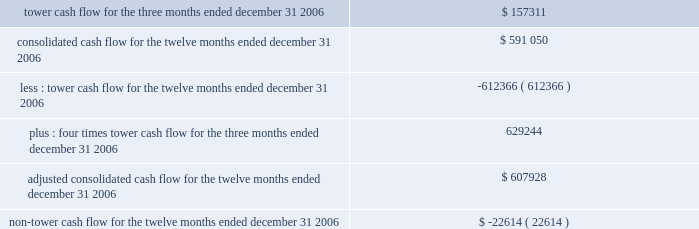In february 2007 , the fasb issued sfas no .
159 201cthe fair value option for financial assets and liabilities 2014including an amendment of fasb statement no .
115 201d ( sfas no .
159 ) .
This statement provides companies with an option to report selected financial assets and liabilities at fair value and establishes presentation and disclosure requirements designed to facilitate comparisons between companies that choose different measurement attributes for similar types of assets and liabilities .
Sfas no .
159 is effective for us as of january 1 , 2008 .
We are in the process of evaluating the impact that sfas no .
159 will have on our consolidated financial statements .
Information presented pursuant to the indentures of our 7.50% ( 7.50 % ) notes , 7.125% ( 7.125 % ) notes and ati 7.25% ( 7.25 % ) the table sets forth information that is presented solely to address certain tower cash flow reporting requirements contained in the indentures for our 7.50% ( 7.50 % ) notes , 7.125% ( 7.125 % ) notes and ati 7.25% ( 7.25 % ) notes ( collectively , the notes ) .
The information contained in note 20 to our consolidated financial statements is also presented to address certain reporting requirements contained in the indenture for our ati 7.25% ( 7.25 % ) notes .
The indentures governing the notes contain restrictive covenants with which we and certain subsidiaries under these indentures must comply .
These include restrictions on our ability to incur additional debt , guarantee debt , pay dividends and make other distributions and make certain investments .
Any failure to comply with these covenants would constitute a default , which could result in the acceleration of the principal amount and accrued and unpaid interest on all the outstanding notes .
In order for the holders of the notes to assess our compliance with certain of these covenants , the indentures require us to disclose in the periodic reports we file with the sec our tower cash flow , adjusted consolidated cash flow and non-tower cash flow ( each as defined in the indentures ) .
Under the indentures , our ability to make certain types of restricted payments is limited by the amount of adjusted consolidated cash flow that we generate , which is determined based on our tower cash flow and non-tower cash flow .
In addition , the indentures for the notes restrict us from incurring additional debt or issuing certain types of preferred stock if on a pro forma basis the issuance of such debt and preferred stock would cause our consolidated debt to be greater than 7.5 times our adjusted consolidated cash flow .
As of december 31 , 2006 , the ratio of our consolidated debt to adjusted consolidated cash flow was approximately 4.6 .
For more information about the restrictions under our notes indentures , see note 7 to our consolidated financial statements included in this annual report and the section entitled 201cmanagement 2019s discussion and analysis of financial condition and results of operations 2014liquidity and capital resources 2014factors affecting sources of liquidity . 201d tower cash flow , adjusted consolidated cash flow and non-tower cash flow are considered non-gaap financial measures .
We are required to provide these financial metrics by the indentures for the notes , and we have included them below because we consider the indentures for the notes to be material agreements , the covenants related to tower cash flow , adjusted consolidated cash flow and non-tower cash flow to be material terms of the indentures , and information about compliance with such covenants to be material to an investor 2019s understanding of our financial results and the impact of those results on our liquidity .
These financial metrics do not include the results of spectrasite or its subsidiaries because such entities are unrestricted subsidiaries under the indentures for the notes .
The table presents tower cash flow , adjusted consolidated cash flow and non-tower cash flow for the company and its restricted subsidiaries , as defined in the indentures for the applicable notes ( in thousands ) : .

What portion of the adjusted consolidated cash flow for the twelve months ended december 31 , 2006 is related to non-tower cash flow? 
Computations: (-22614 / 607928)
Answer: -0.0372. 